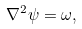<formula> <loc_0><loc_0><loc_500><loc_500>\nabla ^ { 2 } \psi = \omega ,</formula> 